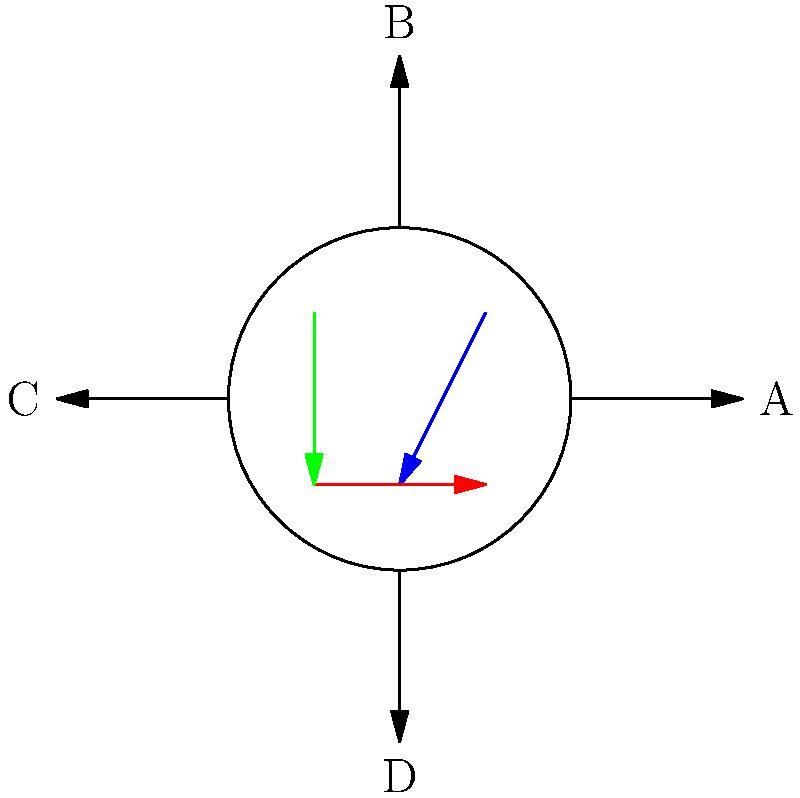At a complex intersection with multiple lanes (A, B, C, and D), you observe the following traffic flow patterns:
1. Blue: from lane B to lane D
2. Red: from lane C to lane A
3. Green: from lane B to lane C

Considering the potential for conflict between these traffic flows, which lane(s) would benefit most from a dedicated turning phase in the traffic signal timing to reduce the risk of collisions? To determine which lane(s) would benefit most from a dedicated turning phase, we need to analyze the potential conflicts between the given traffic flows:

1. Blue flow (B to D): This is a left turn from lane B.
2. Red flow (C to A): This is a straight-through movement from lane C.
3. Green flow (B to C): This is a right turn from lane B.

Step 1: Identify potential conflicts
- The blue flow (left turn from B) conflicts with the red flow (straight from C).
- The green flow (right turn from B) doesn't directly conflict with the other flows.

Step 2: Assess the severity of conflicts
- The conflict between the blue and red flows is the most severe, as it involves a left turn crossing a straight-through movement.

Step 3: Consider traffic volume
- Although we don't have specific volume data, left turns typically have lower volumes than straight-through movements.

Step 4: Evaluate the need for dedicated phases
- The left turn from lane B (blue flow) is the most critical movement in terms of potential conflicts and safety risks.
- Providing a dedicated left-turn phase for lane B would separate this movement from the conflicting straight-through traffic from lane C.

Step 5: Conclusion
Lane B would benefit most from a dedicated turning phase for its left-turn movement (blue flow). This would allow vehicles turning left from B to D to proceed without conflicting with the straight-through traffic from C to A.
Answer: Lane B (for left turns) 